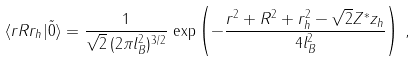<formula> <loc_0><loc_0><loc_500><loc_500>\langle { r } { R } { r } _ { h } | \tilde { 0 } \rangle = \frac { 1 } { \sqrt { 2 } \, ( 2 \pi l _ { B } ^ { 2 } ) ^ { 3 / 2 } } \, \exp \left ( - \frac { { r } ^ { 2 } + { R } ^ { 2 } + { r } _ { h } ^ { 2 } - \sqrt { 2 } Z ^ { \ast } z _ { h } } { 4 l _ { B } ^ { 2 } } \right ) \, ,</formula> 